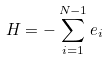<formula> <loc_0><loc_0><loc_500><loc_500>H = - \sum _ { i = 1 } ^ { N - 1 } e _ { i }</formula> 